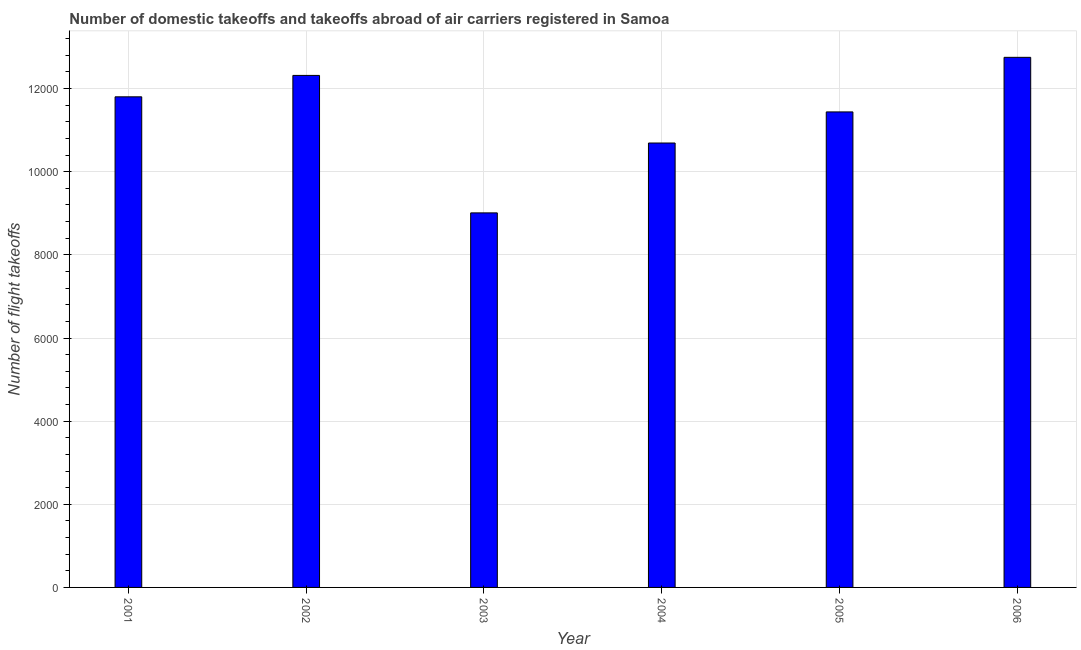Does the graph contain any zero values?
Your answer should be very brief. No. Does the graph contain grids?
Provide a short and direct response. Yes. What is the title of the graph?
Provide a succinct answer. Number of domestic takeoffs and takeoffs abroad of air carriers registered in Samoa. What is the label or title of the X-axis?
Your answer should be very brief. Year. What is the label or title of the Y-axis?
Keep it short and to the point. Number of flight takeoffs. What is the number of flight takeoffs in 2002?
Make the answer very short. 1.23e+04. Across all years, what is the maximum number of flight takeoffs?
Offer a terse response. 1.28e+04. Across all years, what is the minimum number of flight takeoffs?
Offer a very short reply. 9010. In which year was the number of flight takeoffs minimum?
Your answer should be very brief. 2003. What is the sum of the number of flight takeoffs?
Give a very brief answer. 6.80e+04. What is the difference between the number of flight takeoffs in 2004 and 2005?
Ensure brevity in your answer.  -748. What is the average number of flight takeoffs per year?
Your answer should be compact. 1.13e+04. What is the median number of flight takeoffs?
Keep it short and to the point. 1.16e+04. What is the ratio of the number of flight takeoffs in 2004 to that in 2005?
Your response must be concise. 0.94. Is the number of flight takeoffs in 2003 less than that in 2006?
Keep it short and to the point. Yes. Is the difference between the number of flight takeoffs in 2001 and 2004 greater than the difference between any two years?
Offer a very short reply. No. What is the difference between the highest and the second highest number of flight takeoffs?
Offer a terse response. 435. What is the difference between the highest and the lowest number of flight takeoffs?
Offer a very short reply. 3742. In how many years, is the number of flight takeoffs greater than the average number of flight takeoffs taken over all years?
Provide a succinct answer. 4. Are the values on the major ticks of Y-axis written in scientific E-notation?
Give a very brief answer. No. What is the Number of flight takeoffs in 2001?
Offer a very short reply. 1.18e+04. What is the Number of flight takeoffs of 2002?
Ensure brevity in your answer.  1.23e+04. What is the Number of flight takeoffs in 2003?
Your answer should be very brief. 9010. What is the Number of flight takeoffs of 2004?
Keep it short and to the point. 1.07e+04. What is the Number of flight takeoffs of 2005?
Your response must be concise. 1.14e+04. What is the Number of flight takeoffs of 2006?
Your response must be concise. 1.28e+04. What is the difference between the Number of flight takeoffs in 2001 and 2002?
Provide a short and direct response. -515. What is the difference between the Number of flight takeoffs in 2001 and 2003?
Provide a short and direct response. 2792. What is the difference between the Number of flight takeoffs in 2001 and 2004?
Give a very brief answer. 1111. What is the difference between the Number of flight takeoffs in 2001 and 2005?
Keep it short and to the point. 363. What is the difference between the Number of flight takeoffs in 2001 and 2006?
Provide a succinct answer. -950. What is the difference between the Number of flight takeoffs in 2002 and 2003?
Keep it short and to the point. 3307. What is the difference between the Number of flight takeoffs in 2002 and 2004?
Offer a very short reply. 1626. What is the difference between the Number of flight takeoffs in 2002 and 2005?
Keep it short and to the point. 878. What is the difference between the Number of flight takeoffs in 2002 and 2006?
Make the answer very short. -435. What is the difference between the Number of flight takeoffs in 2003 and 2004?
Provide a succinct answer. -1681. What is the difference between the Number of flight takeoffs in 2003 and 2005?
Your answer should be compact. -2429. What is the difference between the Number of flight takeoffs in 2003 and 2006?
Ensure brevity in your answer.  -3742. What is the difference between the Number of flight takeoffs in 2004 and 2005?
Offer a very short reply. -748. What is the difference between the Number of flight takeoffs in 2004 and 2006?
Offer a very short reply. -2061. What is the difference between the Number of flight takeoffs in 2005 and 2006?
Your answer should be compact. -1313. What is the ratio of the Number of flight takeoffs in 2001 to that in 2002?
Provide a short and direct response. 0.96. What is the ratio of the Number of flight takeoffs in 2001 to that in 2003?
Give a very brief answer. 1.31. What is the ratio of the Number of flight takeoffs in 2001 to that in 2004?
Keep it short and to the point. 1.1. What is the ratio of the Number of flight takeoffs in 2001 to that in 2005?
Your answer should be very brief. 1.03. What is the ratio of the Number of flight takeoffs in 2001 to that in 2006?
Keep it short and to the point. 0.93. What is the ratio of the Number of flight takeoffs in 2002 to that in 2003?
Give a very brief answer. 1.37. What is the ratio of the Number of flight takeoffs in 2002 to that in 2004?
Your answer should be compact. 1.15. What is the ratio of the Number of flight takeoffs in 2002 to that in 2005?
Ensure brevity in your answer.  1.08. What is the ratio of the Number of flight takeoffs in 2003 to that in 2004?
Provide a succinct answer. 0.84. What is the ratio of the Number of flight takeoffs in 2003 to that in 2005?
Make the answer very short. 0.79. What is the ratio of the Number of flight takeoffs in 2003 to that in 2006?
Give a very brief answer. 0.71. What is the ratio of the Number of flight takeoffs in 2004 to that in 2005?
Provide a short and direct response. 0.94. What is the ratio of the Number of flight takeoffs in 2004 to that in 2006?
Offer a terse response. 0.84. What is the ratio of the Number of flight takeoffs in 2005 to that in 2006?
Ensure brevity in your answer.  0.9. 